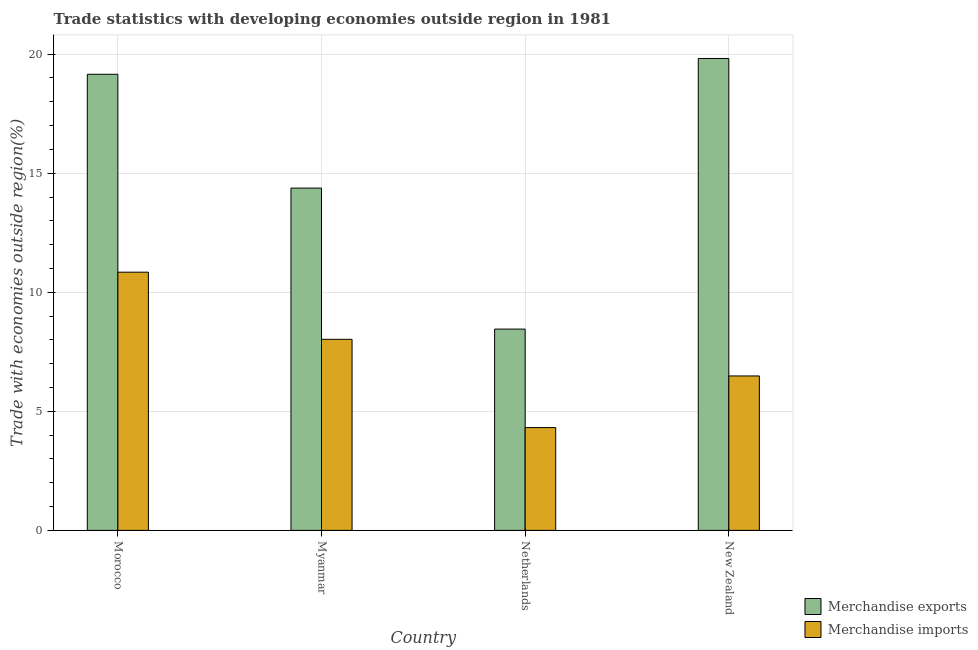How many groups of bars are there?
Ensure brevity in your answer.  4. Are the number of bars per tick equal to the number of legend labels?
Provide a short and direct response. Yes. Are the number of bars on each tick of the X-axis equal?
Your answer should be compact. Yes. How many bars are there on the 3rd tick from the right?
Provide a short and direct response. 2. What is the label of the 2nd group of bars from the left?
Keep it short and to the point. Myanmar. In how many cases, is the number of bars for a given country not equal to the number of legend labels?
Give a very brief answer. 0. What is the merchandise exports in Morocco?
Offer a very short reply. 19.16. Across all countries, what is the maximum merchandise imports?
Keep it short and to the point. 10.84. Across all countries, what is the minimum merchandise imports?
Offer a terse response. 4.32. In which country was the merchandise exports maximum?
Ensure brevity in your answer.  New Zealand. What is the total merchandise imports in the graph?
Keep it short and to the point. 29.67. What is the difference between the merchandise exports in Morocco and that in Myanmar?
Your answer should be compact. 4.78. What is the difference between the merchandise exports in New Zealand and the merchandise imports in Myanmar?
Ensure brevity in your answer.  11.79. What is the average merchandise exports per country?
Your answer should be compact. 15.45. What is the difference between the merchandise exports and merchandise imports in Morocco?
Provide a succinct answer. 8.31. In how many countries, is the merchandise exports greater than 9 %?
Keep it short and to the point. 3. What is the ratio of the merchandise imports in Morocco to that in Netherlands?
Keep it short and to the point. 2.51. Is the difference between the merchandise imports in Morocco and New Zealand greater than the difference between the merchandise exports in Morocco and New Zealand?
Give a very brief answer. Yes. What is the difference between the highest and the second highest merchandise imports?
Provide a succinct answer. 2.82. What is the difference between the highest and the lowest merchandise exports?
Keep it short and to the point. 11.36. In how many countries, is the merchandise imports greater than the average merchandise imports taken over all countries?
Provide a short and direct response. 2. What does the 2nd bar from the left in Morocco represents?
Your answer should be very brief. Merchandise imports. How many bars are there?
Ensure brevity in your answer.  8. What is the difference between two consecutive major ticks on the Y-axis?
Provide a succinct answer. 5. Are the values on the major ticks of Y-axis written in scientific E-notation?
Give a very brief answer. No. Where does the legend appear in the graph?
Make the answer very short. Bottom right. What is the title of the graph?
Ensure brevity in your answer.  Trade statistics with developing economies outside region in 1981. What is the label or title of the X-axis?
Provide a short and direct response. Country. What is the label or title of the Y-axis?
Give a very brief answer. Trade with economies outside region(%). What is the Trade with economies outside region(%) of Merchandise exports in Morocco?
Give a very brief answer. 19.16. What is the Trade with economies outside region(%) of Merchandise imports in Morocco?
Your answer should be compact. 10.84. What is the Trade with economies outside region(%) in Merchandise exports in Myanmar?
Your answer should be very brief. 14.38. What is the Trade with economies outside region(%) in Merchandise imports in Myanmar?
Your answer should be very brief. 8.02. What is the Trade with economies outside region(%) in Merchandise exports in Netherlands?
Your response must be concise. 8.45. What is the Trade with economies outside region(%) in Merchandise imports in Netherlands?
Ensure brevity in your answer.  4.32. What is the Trade with economies outside region(%) in Merchandise exports in New Zealand?
Provide a succinct answer. 19.82. What is the Trade with economies outside region(%) of Merchandise imports in New Zealand?
Provide a short and direct response. 6.49. Across all countries, what is the maximum Trade with economies outside region(%) of Merchandise exports?
Your response must be concise. 19.82. Across all countries, what is the maximum Trade with economies outside region(%) in Merchandise imports?
Your answer should be compact. 10.84. Across all countries, what is the minimum Trade with economies outside region(%) of Merchandise exports?
Make the answer very short. 8.45. Across all countries, what is the minimum Trade with economies outside region(%) in Merchandise imports?
Offer a terse response. 4.32. What is the total Trade with economies outside region(%) in Merchandise exports in the graph?
Keep it short and to the point. 61.81. What is the total Trade with economies outside region(%) of Merchandise imports in the graph?
Keep it short and to the point. 29.67. What is the difference between the Trade with economies outside region(%) in Merchandise exports in Morocco and that in Myanmar?
Make the answer very short. 4.78. What is the difference between the Trade with economies outside region(%) of Merchandise imports in Morocco and that in Myanmar?
Provide a succinct answer. 2.82. What is the difference between the Trade with economies outside region(%) of Merchandise exports in Morocco and that in Netherlands?
Make the answer very short. 10.7. What is the difference between the Trade with economies outside region(%) in Merchandise imports in Morocco and that in Netherlands?
Your answer should be very brief. 6.53. What is the difference between the Trade with economies outside region(%) in Merchandise exports in Morocco and that in New Zealand?
Your answer should be very brief. -0.66. What is the difference between the Trade with economies outside region(%) of Merchandise imports in Morocco and that in New Zealand?
Offer a very short reply. 4.36. What is the difference between the Trade with economies outside region(%) in Merchandise exports in Myanmar and that in Netherlands?
Offer a very short reply. 5.92. What is the difference between the Trade with economies outside region(%) of Merchandise imports in Myanmar and that in Netherlands?
Your answer should be compact. 3.71. What is the difference between the Trade with economies outside region(%) in Merchandise exports in Myanmar and that in New Zealand?
Offer a terse response. -5.44. What is the difference between the Trade with economies outside region(%) in Merchandise imports in Myanmar and that in New Zealand?
Keep it short and to the point. 1.54. What is the difference between the Trade with economies outside region(%) of Merchandise exports in Netherlands and that in New Zealand?
Give a very brief answer. -11.36. What is the difference between the Trade with economies outside region(%) in Merchandise imports in Netherlands and that in New Zealand?
Offer a terse response. -2.17. What is the difference between the Trade with economies outside region(%) in Merchandise exports in Morocco and the Trade with economies outside region(%) in Merchandise imports in Myanmar?
Make the answer very short. 11.13. What is the difference between the Trade with economies outside region(%) of Merchandise exports in Morocco and the Trade with economies outside region(%) of Merchandise imports in Netherlands?
Your answer should be very brief. 14.84. What is the difference between the Trade with economies outside region(%) in Merchandise exports in Morocco and the Trade with economies outside region(%) in Merchandise imports in New Zealand?
Keep it short and to the point. 12.67. What is the difference between the Trade with economies outside region(%) of Merchandise exports in Myanmar and the Trade with economies outside region(%) of Merchandise imports in Netherlands?
Ensure brevity in your answer.  10.06. What is the difference between the Trade with economies outside region(%) in Merchandise exports in Myanmar and the Trade with economies outside region(%) in Merchandise imports in New Zealand?
Your answer should be compact. 7.89. What is the difference between the Trade with economies outside region(%) in Merchandise exports in Netherlands and the Trade with economies outside region(%) in Merchandise imports in New Zealand?
Your answer should be compact. 1.97. What is the average Trade with economies outside region(%) in Merchandise exports per country?
Ensure brevity in your answer.  15.45. What is the average Trade with economies outside region(%) in Merchandise imports per country?
Give a very brief answer. 7.42. What is the difference between the Trade with economies outside region(%) of Merchandise exports and Trade with economies outside region(%) of Merchandise imports in Morocco?
Offer a very short reply. 8.31. What is the difference between the Trade with economies outside region(%) in Merchandise exports and Trade with economies outside region(%) in Merchandise imports in Myanmar?
Offer a terse response. 6.35. What is the difference between the Trade with economies outside region(%) in Merchandise exports and Trade with economies outside region(%) in Merchandise imports in Netherlands?
Give a very brief answer. 4.14. What is the difference between the Trade with economies outside region(%) of Merchandise exports and Trade with economies outside region(%) of Merchandise imports in New Zealand?
Provide a succinct answer. 13.33. What is the ratio of the Trade with economies outside region(%) of Merchandise exports in Morocco to that in Myanmar?
Your response must be concise. 1.33. What is the ratio of the Trade with economies outside region(%) of Merchandise imports in Morocco to that in Myanmar?
Give a very brief answer. 1.35. What is the ratio of the Trade with economies outside region(%) in Merchandise exports in Morocco to that in Netherlands?
Your answer should be very brief. 2.27. What is the ratio of the Trade with economies outside region(%) of Merchandise imports in Morocco to that in Netherlands?
Your response must be concise. 2.51. What is the ratio of the Trade with economies outside region(%) of Merchandise exports in Morocco to that in New Zealand?
Your answer should be very brief. 0.97. What is the ratio of the Trade with economies outside region(%) of Merchandise imports in Morocco to that in New Zealand?
Your response must be concise. 1.67. What is the ratio of the Trade with economies outside region(%) of Merchandise exports in Myanmar to that in Netherlands?
Offer a very short reply. 1.7. What is the ratio of the Trade with economies outside region(%) of Merchandise imports in Myanmar to that in Netherlands?
Give a very brief answer. 1.86. What is the ratio of the Trade with economies outside region(%) of Merchandise exports in Myanmar to that in New Zealand?
Keep it short and to the point. 0.73. What is the ratio of the Trade with economies outside region(%) in Merchandise imports in Myanmar to that in New Zealand?
Your response must be concise. 1.24. What is the ratio of the Trade with economies outside region(%) in Merchandise exports in Netherlands to that in New Zealand?
Your answer should be compact. 0.43. What is the ratio of the Trade with economies outside region(%) of Merchandise imports in Netherlands to that in New Zealand?
Your answer should be very brief. 0.67. What is the difference between the highest and the second highest Trade with economies outside region(%) in Merchandise exports?
Provide a short and direct response. 0.66. What is the difference between the highest and the second highest Trade with economies outside region(%) of Merchandise imports?
Provide a succinct answer. 2.82. What is the difference between the highest and the lowest Trade with economies outside region(%) of Merchandise exports?
Provide a succinct answer. 11.36. What is the difference between the highest and the lowest Trade with economies outside region(%) of Merchandise imports?
Offer a very short reply. 6.53. 